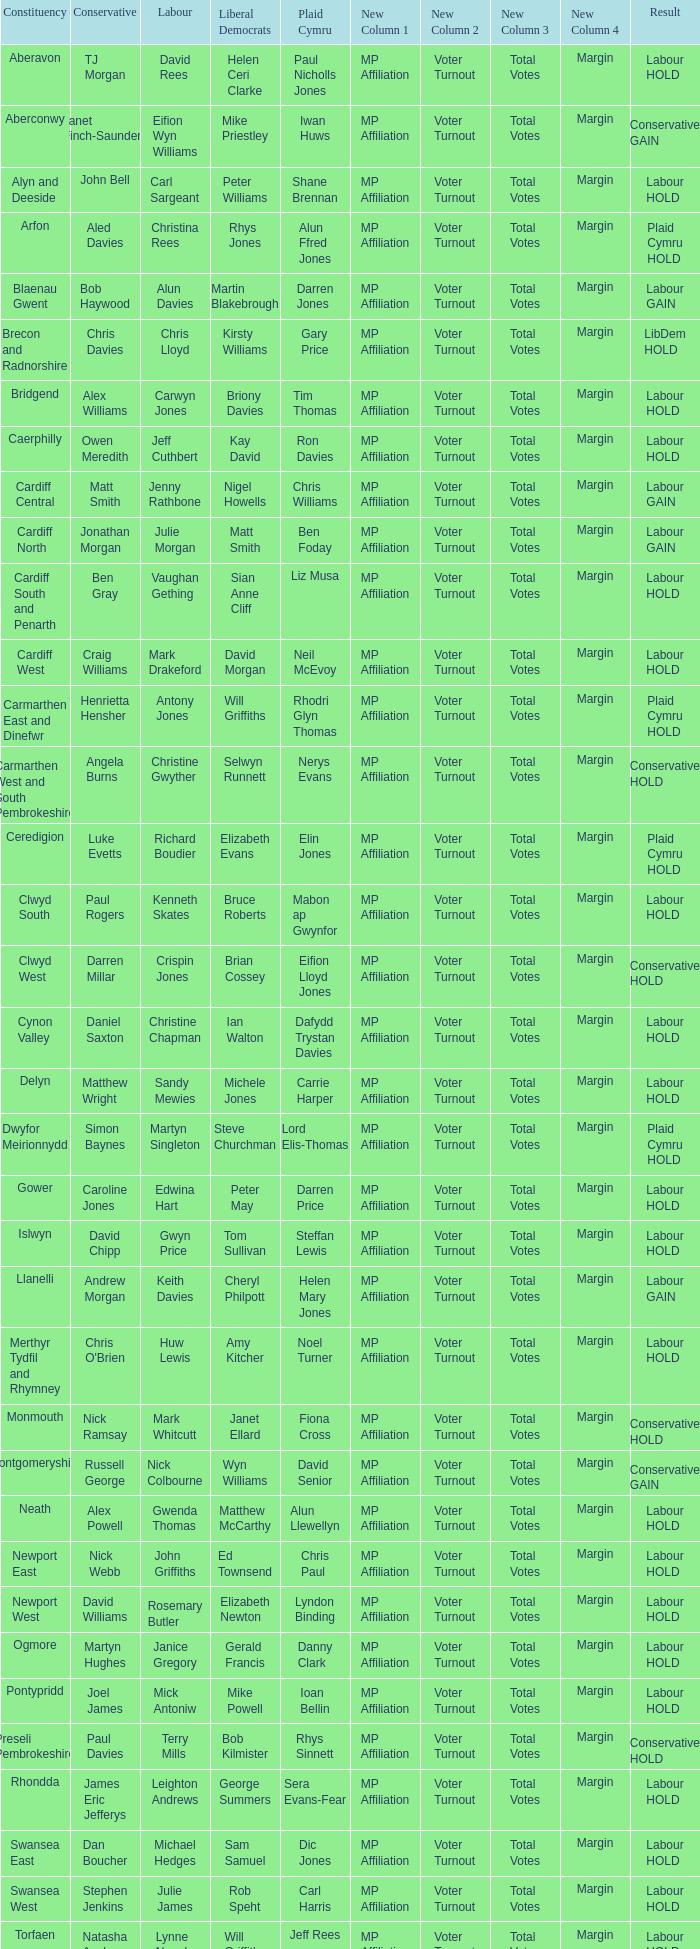In what constituency was the result labour hold and Liberal democrat Elizabeth Newton won? Newport West. 